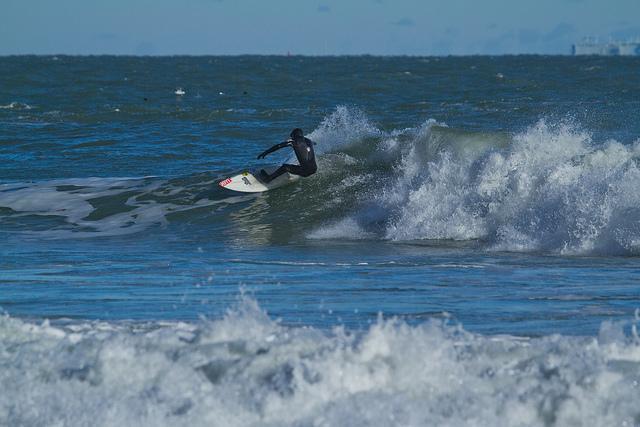How many people are surfing?
Give a very brief answer. 1. How many blue train cars are there?
Give a very brief answer. 0. 